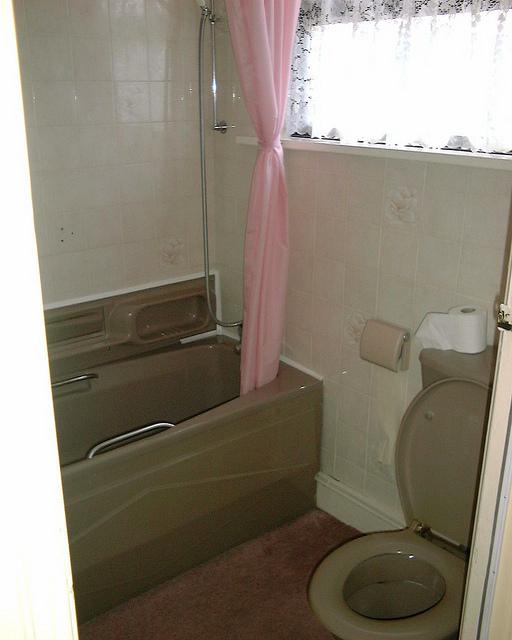What is hanging above the bathtub?
Concise answer only. Shower curtain. How many rolls of toilet paper are there?
Short answer required. 2. What room is this?
Write a very short answer. Bathroom. What color is the curtain?
Give a very brief answer. Pink. Is the toilet lid, up or down?
Quick response, please. Up. What is the floor made of?
Answer briefly. Carpet. 